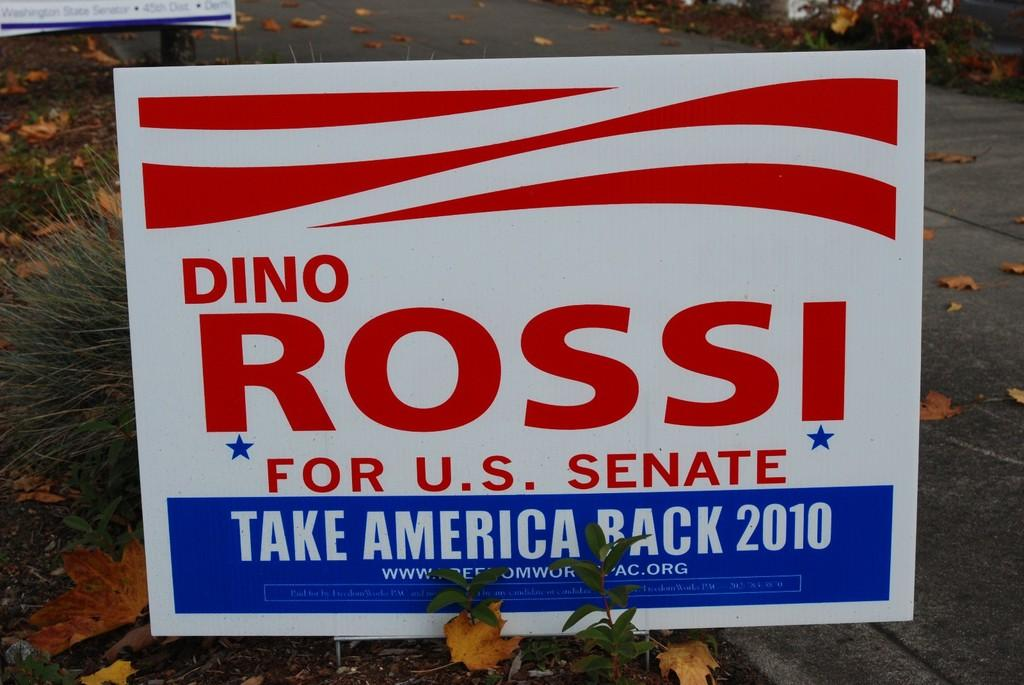<image>
Create a compact narrative representing the image presented. A Dino Rossi sign says he is running for U.S. Senate in 2010. 